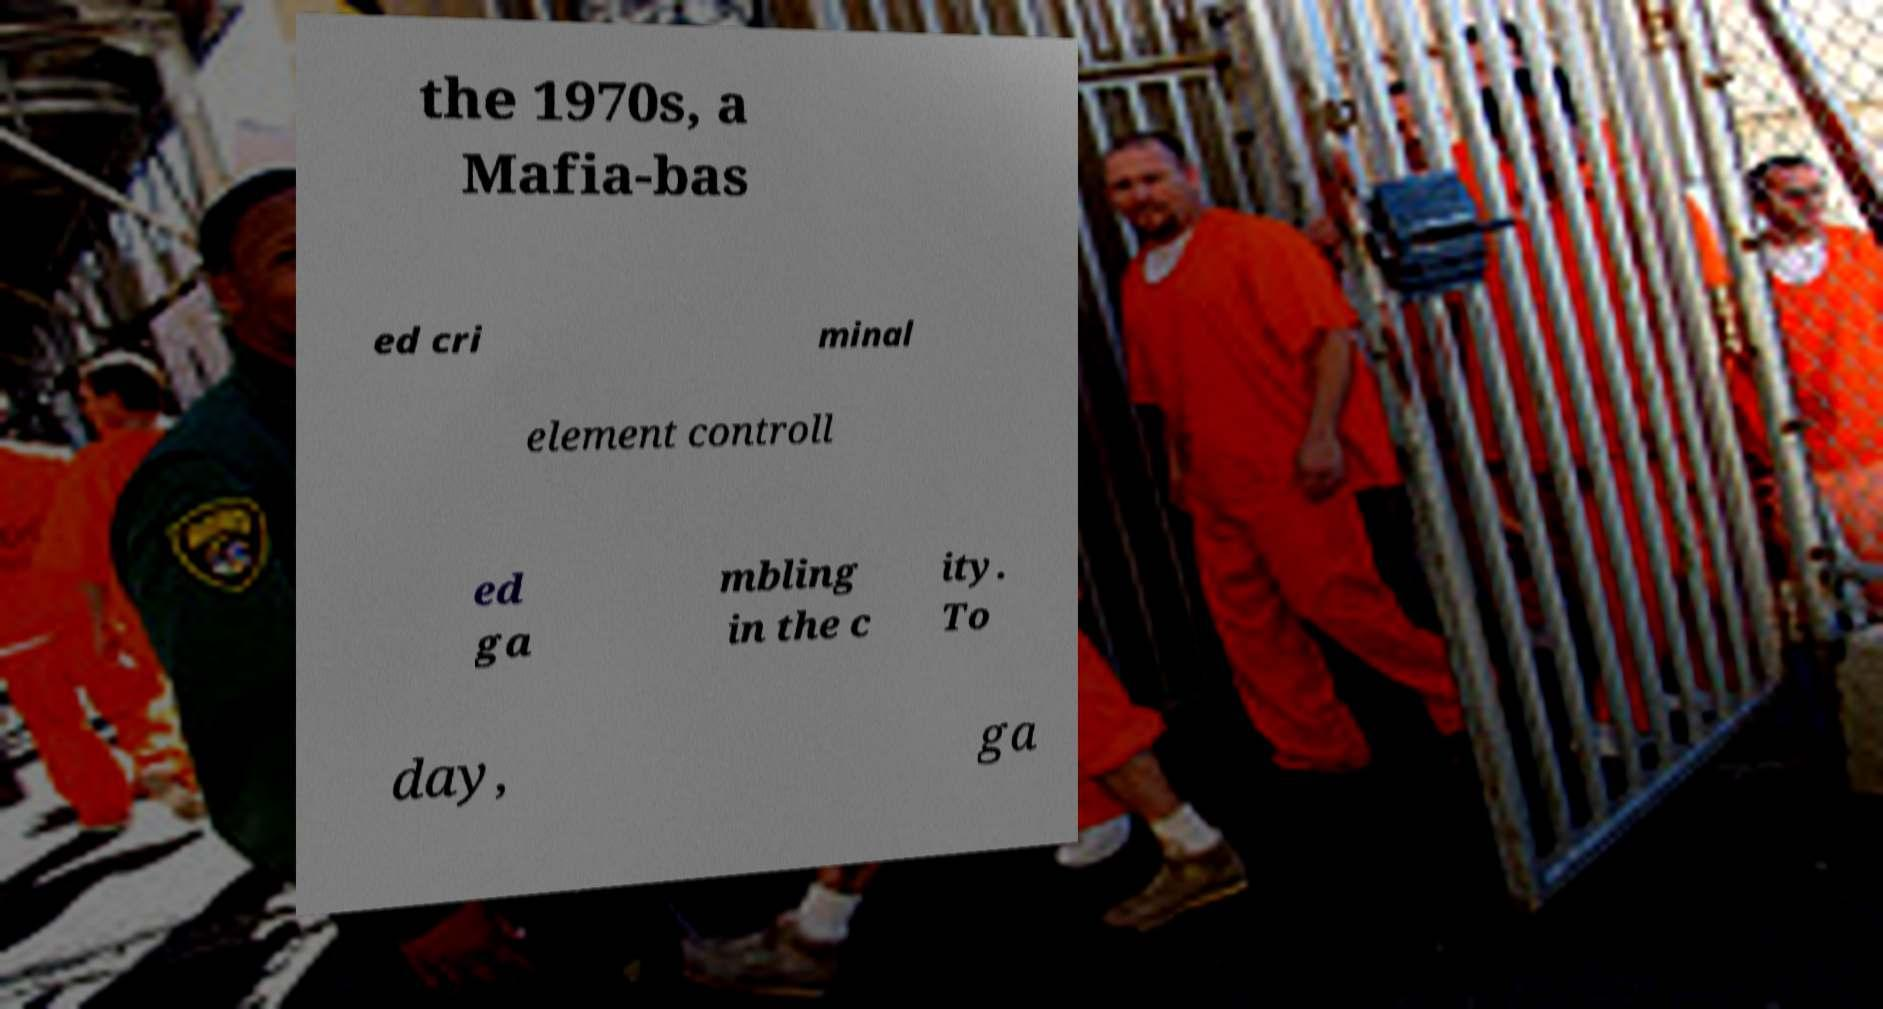There's text embedded in this image that I need extracted. Can you transcribe it verbatim? the 1970s, a Mafia-bas ed cri minal element controll ed ga mbling in the c ity. To day, ga 